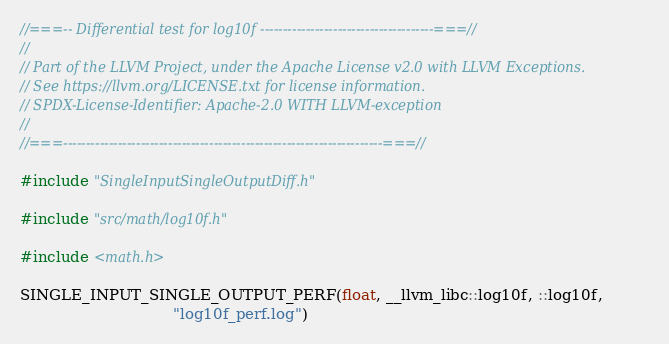<code> <loc_0><loc_0><loc_500><loc_500><_C++_>//===-- Differential test for log10f --------------------------------------===//
//
// Part of the LLVM Project, under the Apache License v2.0 with LLVM Exceptions.
// See https://llvm.org/LICENSE.txt for license information.
// SPDX-License-Identifier: Apache-2.0 WITH LLVM-exception
//
//===----------------------------------------------------------------------===//

#include "SingleInputSingleOutputDiff.h"

#include "src/math/log10f.h"

#include <math.h>

SINGLE_INPUT_SINGLE_OUTPUT_PERF(float, __llvm_libc::log10f, ::log10f,
                                "log10f_perf.log")
</code> 